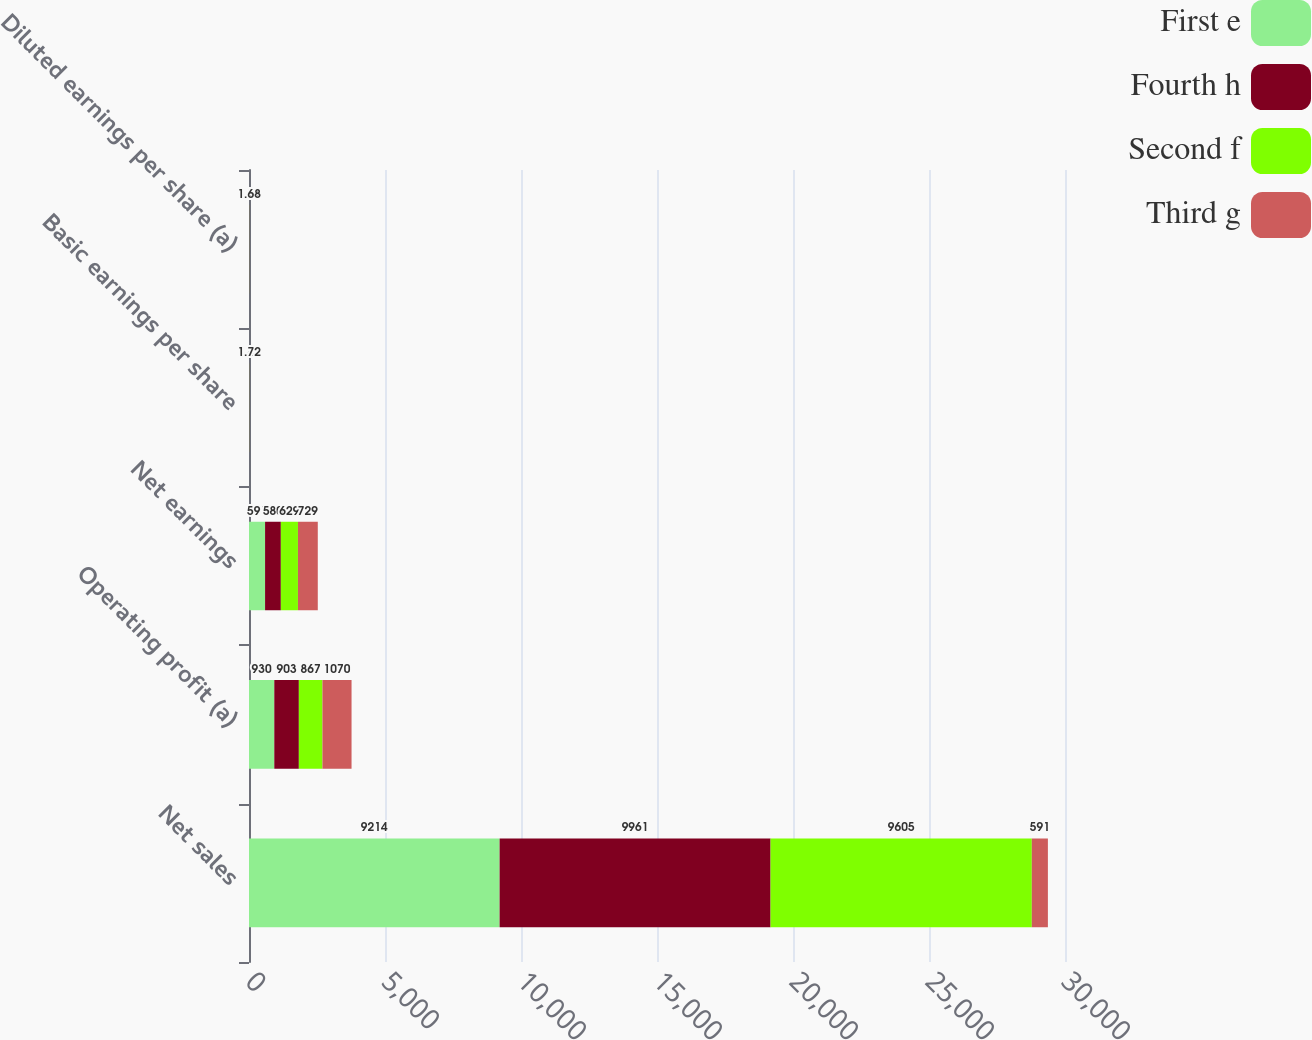Convert chart to OTSL. <chart><loc_0><loc_0><loc_500><loc_500><stacked_bar_chart><ecel><fcel>Net sales<fcel>Operating profit (a)<fcel>Net earnings<fcel>Basic earnings per share<fcel>Diluted earnings per share (a)<nl><fcel>First e<fcel>9214<fcel>930<fcel>591<fcel>1.36<fcel>1.34<nl><fcel>Fourth h<fcel>9961<fcel>903<fcel>580<fcel>1.35<fcel>1.34<nl><fcel>Second f<fcel>9605<fcel>867<fcel>629<fcel>1.48<fcel>1.46<nl><fcel>Third g<fcel>591<fcel>1070<fcel>729<fcel>1.72<fcel>1.68<nl></chart> 